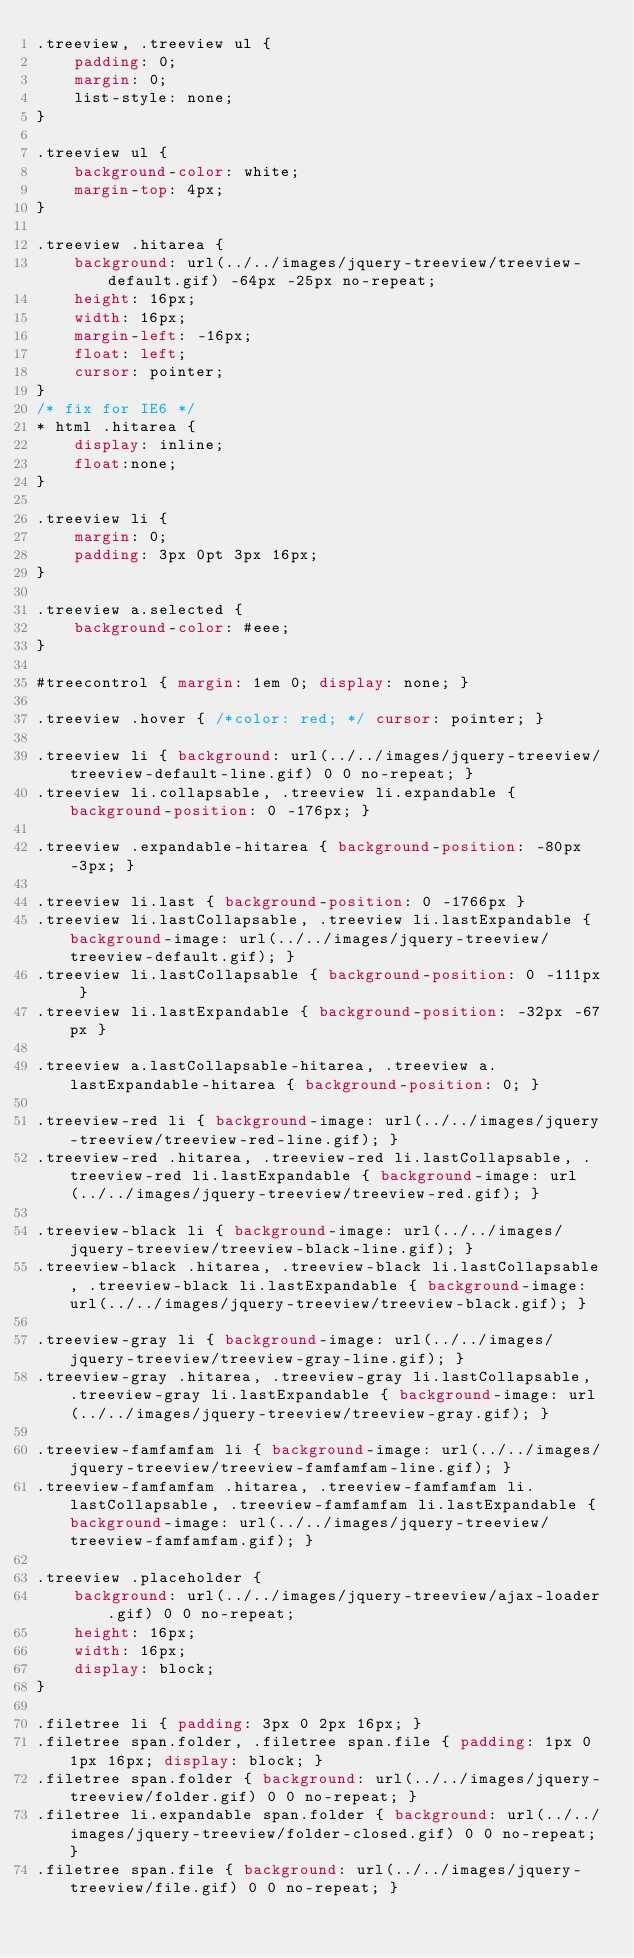Convert code to text. <code><loc_0><loc_0><loc_500><loc_500><_CSS_>.treeview, .treeview ul { 
	padding: 0;
	margin: 0;
	list-style: none;
}

.treeview ul {
	background-color: white;
	margin-top: 4px;
}

.treeview .hitarea {
	background: url(../../images/jquery-treeview/treeview-default.gif) -64px -25px no-repeat;
	height: 16px;
	width: 16px;
	margin-left: -16px;
	float: left;
	cursor: pointer;
}
/* fix for IE6 */
* html .hitarea {
	display: inline;
	float:none;
}

.treeview li { 
	margin: 0;
	padding: 3px 0pt 3px 16px;
}

.treeview a.selected {
	background-color: #eee;
}

#treecontrol { margin: 1em 0; display: none; }

.treeview .hover { /*color: red; */ cursor: pointer; }

.treeview li { background: url(../../images/jquery-treeview/treeview-default-line.gif) 0 0 no-repeat; }
.treeview li.collapsable, .treeview li.expandable { background-position: 0 -176px; }

.treeview .expandable-hitarea { background-position: -80px -3px; }

.treeview li.last { background-position: 0 -1766px }
.treeview li.lastCollapsable, .treeview li.lastExpandable { background-image: url(../../images/jquery-treeview/treeview-default.gif); }  
.treeview li.lastCollapsable { background-position: 0 -111px }
.treeview li.lastExpandable { background-position: -32px -67px }

.treeview a.lastCollapsable-hitarea, .treeview a.lastExpandable-hitarea { background-position: 0; }

.treeview-red li { background-image: url(../../images/jquery-treeview/treeview-red-line.gif); }
.treeview-red .hitarea, .treeview-red li.lastCollapsable, .treeview-red li.lastExpandable { background-image: url(../../images/jquery-treeview/treeview-red.gif); } 

.treeview-black li { background-image: url(../../images/jquery-treeview/treeview-black-line.gif); }
.treeview-black .hitarea, .treeview-black li.lastCollapsable, .treeview-black li.lastExpandable { background-image: url(../../images/jquery-treeview/treeview-black.gif); }  

.treeview-gray li { background-image: url(../../images/jquery-treeview/treeview-gray-line.gif); }
.treeview-gray .hitarea, .treeview-gray li.lastCollapsable, .treeview-gray li.lastExpandable { background-image: url(../../images/jquery-treeview/treeview-gray.gif); } 

.treeview-famfamfam li { background-image: url(../../images/jquery-treeview/treeview-famfamfam-line.gif); }
.treeview-famfamfam .hitarea, .treeview-famfamfam li.lastCollapsable, .treeview-famfamfam li.lastExpandable { background-image: url(../../images/jquery-treeview/treeview-famfamfam.gif); } 

.treeview .placeholder {
	background: url(../../images/jquery-treeview/ajax-loader.gif) 0 0 no-repeat;
	height: 16px;
	width: 16px;
	display: block;
}

.filetree li { padding: 3px 0 2px 16px; }
.filetree span.folder, .filetree span.file { padding: 1px 0 1px 16px; display: block; }
.filetree span.folder { background: url(../../images/jquery-treeview/folder.gif) 0 0 no-repeat; }
.filetree li.expandable span.folder { background: url(../../images/jquery-treeview/folder-closed.gif) 0 0 no-repeat; }
.filetree span.file { background: url(../../images/jquery-treeview/file.gif) 0 0 no-repeat; }
</code> 